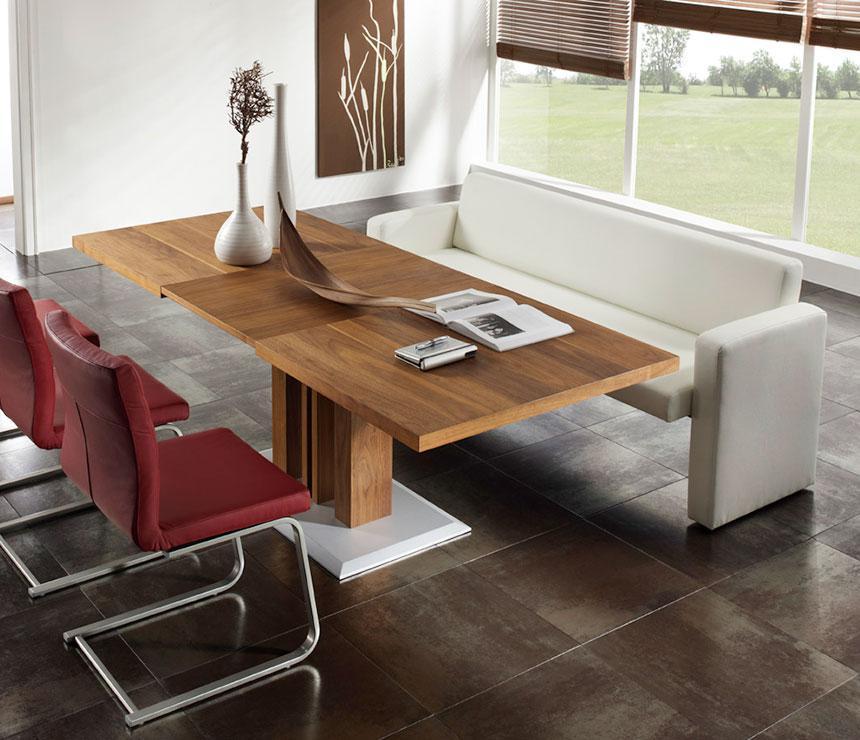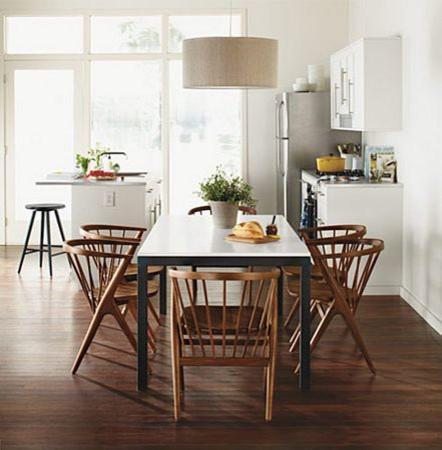The first image is the image on the left, the second image is the image on the right. Given the left and right images, does the statement "In one of the images, there is a dining table and chairs placed over an area rug." hold true? Answer yes or no. No. 